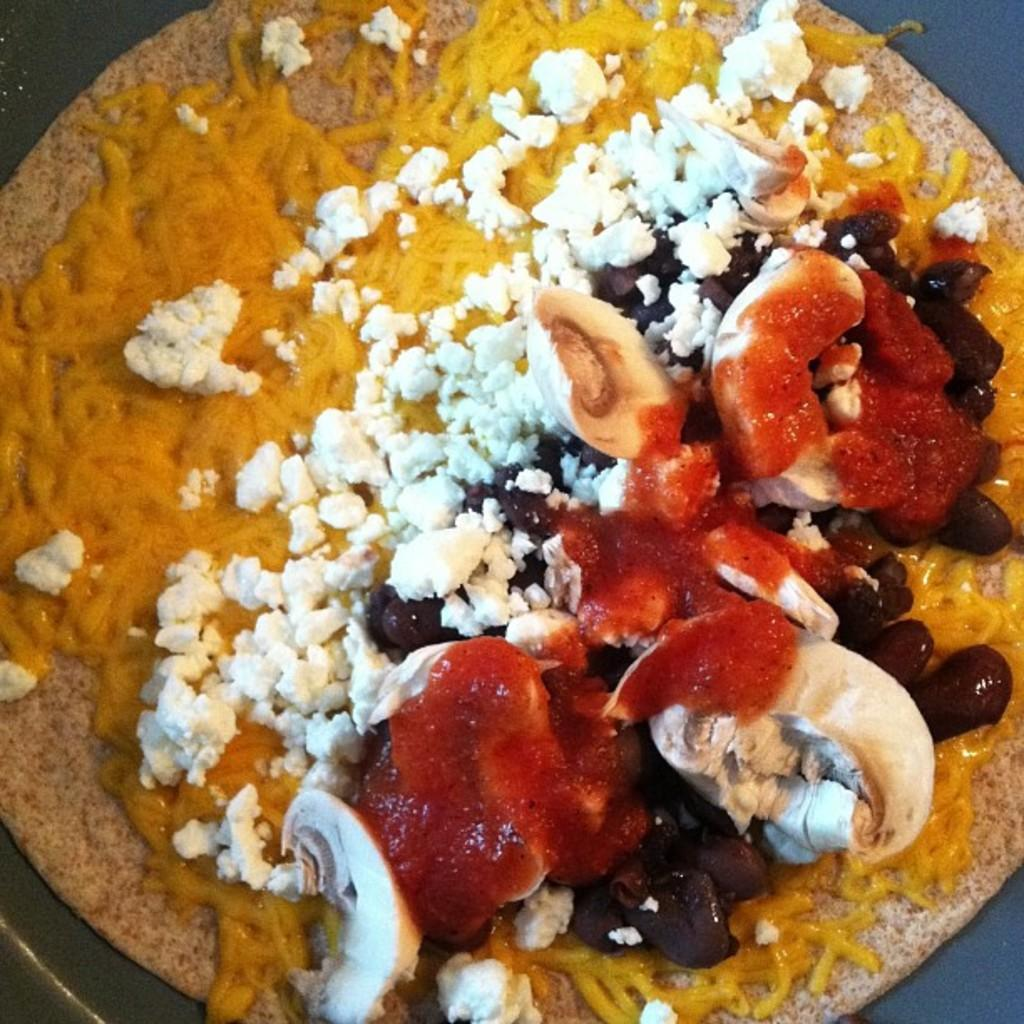What is the main subject of the image? The main subject of the image is a dish. Can you describe the dish in the image? The dish appears to be a dessert. What is the condition of the baseball field in the image? There is no baseball field present in the image; it only features a dish that appears to be a dessert. 